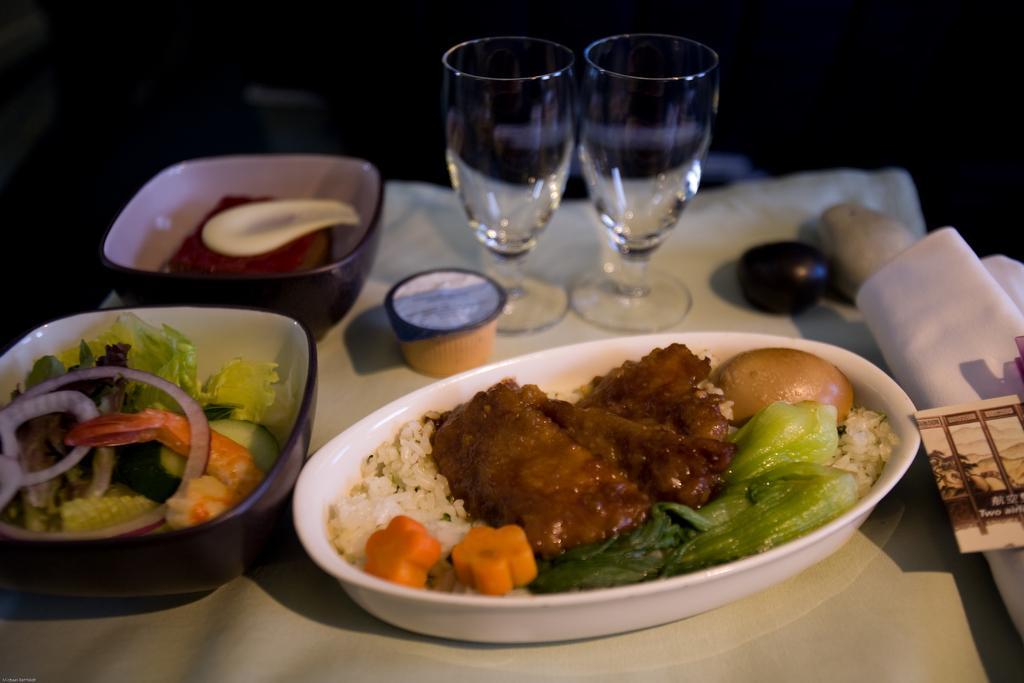Can you describe this image briefly? In this image we can see three bowls of different kinds of foods and I can see two champagne glasses at the top of the image and this image is clicked in dark and I can see a piece of paper in right bottom corner. 